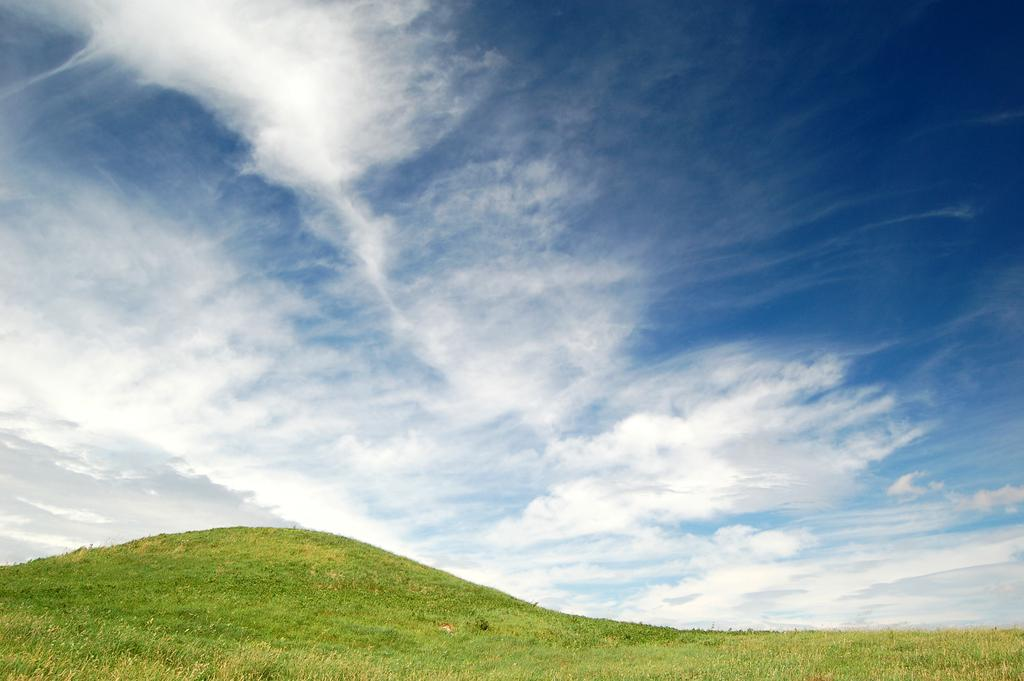What type of vegetation can be seen in the image? There is grass in the image. What is visible in the background of the image? The sky is visible in the background of the image. What can be observed in the sky? There are clouds in the sky. What type of pump is visible in the image? There is no pump present in the image. What is the color of the neck of the person in the image? There is no person present in the image, so we cannot determine the color of their neck. 